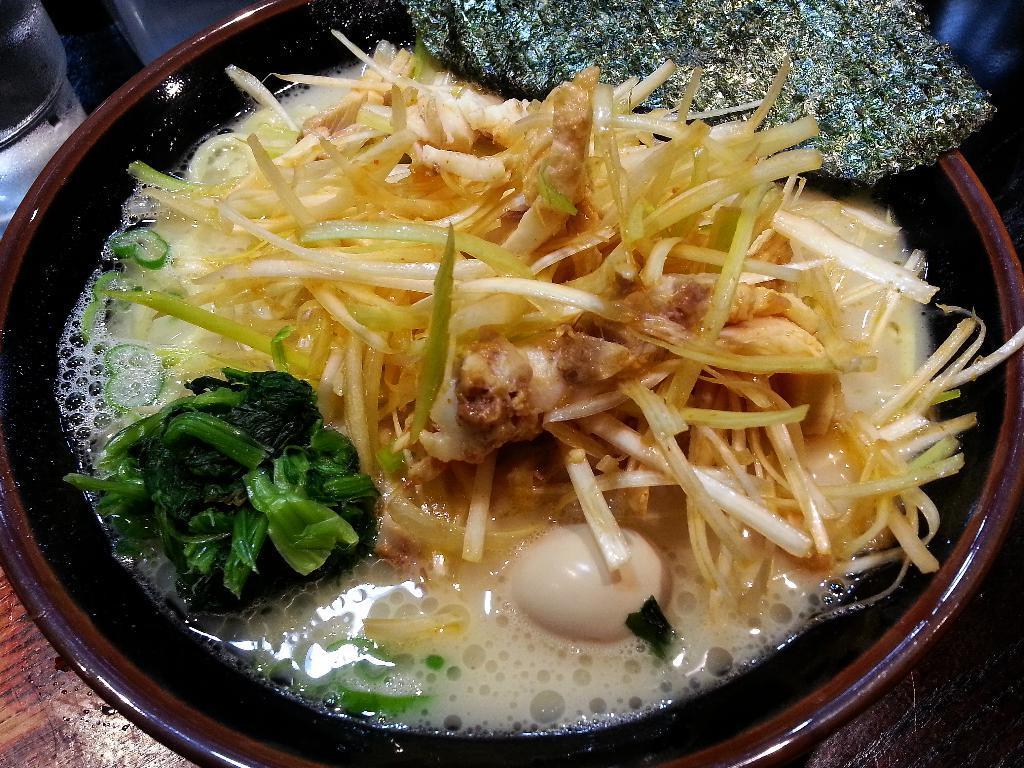Describe this image in one or two sentences. In the picture we can see the food in the bowl. 